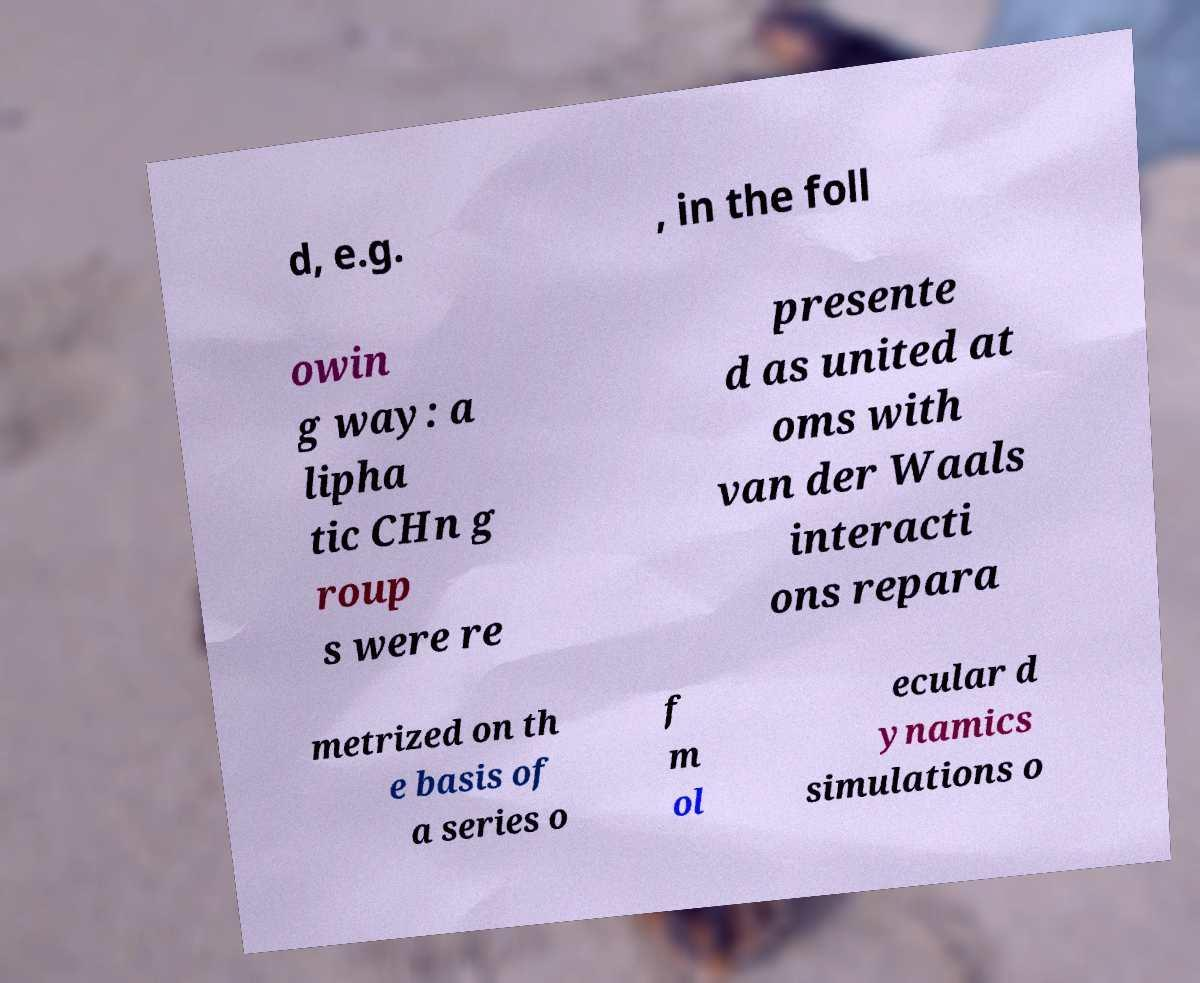I need the written content from this picture converted into text. Can you do that? d, e.g. , in the foll owin g way: a lipha tic CHn g roup s were re presente d as united at oms with van der Waals interacti ons repara metrized on th e basis of a series o f m ol ecular d ynamics simulations o 